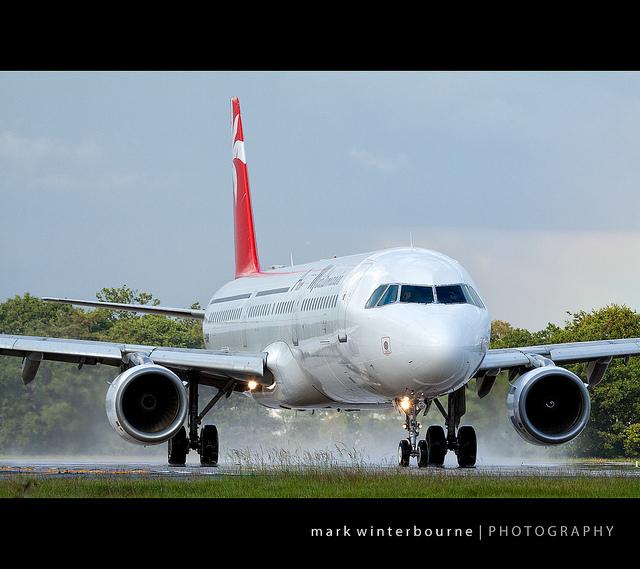Is the plane landing?
Concise answer only. Yes. Whose name is in this picture?
Give a very brief answer. Mark winterbourne. Is this a two engine plane?
Short answer required. Yes. Is this a professional picture of an airplane?
Concise answer only. Yes. How many lights can you see on the plane?
Give a very brief answer. 2. 